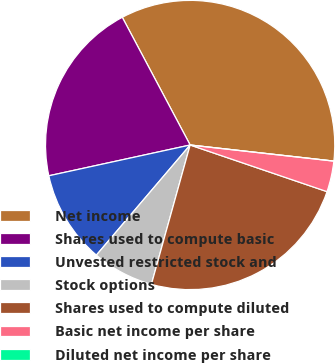Convert chart. <chart><loc_0><loc_0><loc_500><loc_500><pie_chart><fcel>Net income<fcel>Shares used to compute basic<fcel>Unvested restricted stock and<fcel>Stock options<fcel>Shares used to compute diluted<fcel>Basic net income per share<fcel>Diluted net income per share<nl><fcel>34.55%<fcel>20.64%<fcel>10.36%<fcel>6.91%<fcel>24.09%<fcel>3.45%<fcel>0.0%<nl></chart> 